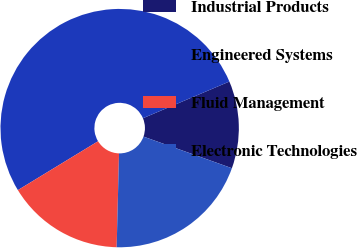<chart> <loc_0><loc_0><loc_500><loc_500><pie_chart><fcel>Industrial Products<fcel>Engineered Systems<fcel>Fluid Management<fcel>Electronic Technologies<nl><fcel>11.85%<fcel>52.32%<fcel>15.89%<fcel>19.94%<nl></chart> 